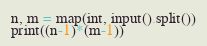<code> <loc_0><loc_0><loc_500><loc_500><_Python_>n, m = map(int, input().split())
print((n-1)*(m-1))
</code> 